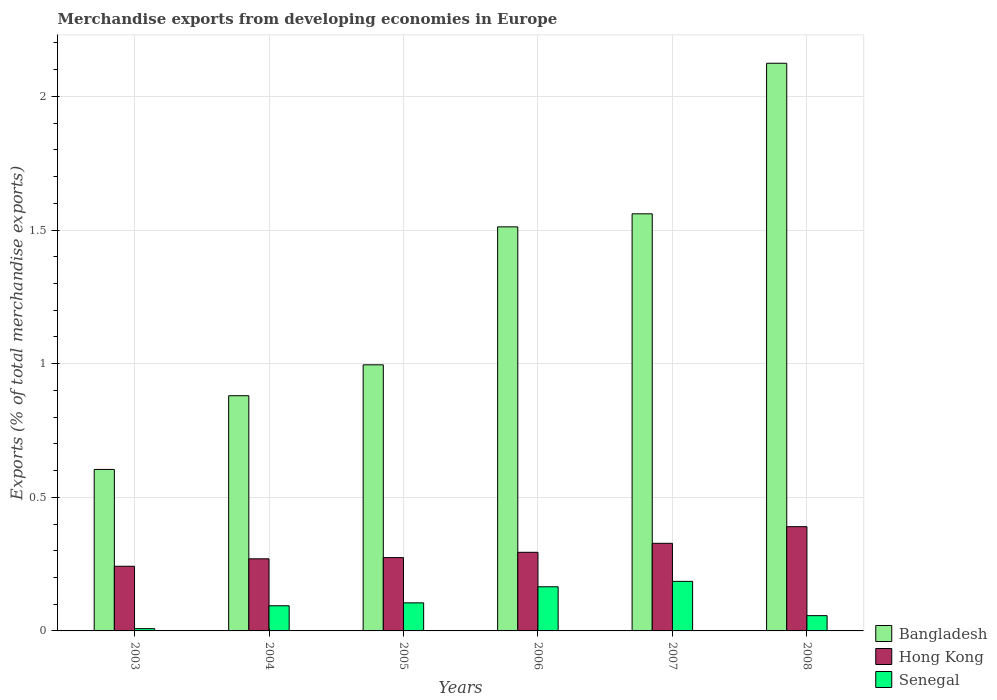How many different coloured bars are there?
Make the answer very short. 3. How many groups of bars are there?
Give a very brief answer. 6. How many bars are there on the 3rd tick from the right?
Your answer should be compact. 3. In how many cases, is the number of bars for a given year not equal to the number of legend labels?
Provide a succinct answer. 0. What is the percentage of total merchandise exports in Senegal in 2003?
Your response must be concise. 0.01. Across all years, what is the maximum percentage of total merchandise exports in Bangladesh?
Your answer should be very brief. 2.12. Across all years, what is the minimum percentage of total merchandise exports in Hong Kong?
Your answer should be very brief. 0.24. In which year was the percentage of total merchandise exports in Bangladesh maximum?
Your answer should be very brief. 2008. In which year was the percentage of total merchandise exports in Bangladesh minimum?
Offer a very short reply. 2003. What is the total percentage of total merchandise exports in Bangladesh in the graph?
Provide a short and direct response. 7.68. What is the difference between the percentage of total merchandise exports in Bangladesh in 2003 and that in 2008?
Make the answer very short. -1.52. What is the difference between the percentage of total merchandise exports in Hong Kong in 2007 and the percentage of total merchandise exports in Senegal in 2003?
Provide a short and direct response. 0.32. What is the average percentage of total merchandise exports in Bangladesh per year?
Make the answer very short. 1.28. In the year 2007, what is the difference between the percentage of total merchandise exports in Hong Kong and percentage of total merchandise exports in Bangladesh?
Your answer should be very brief. -1.23. In how many years, is the percentage of total merchandise exports in Bangladesh greater than 0.7 %?
Provide a short and direct response. 5. What is the ratio of the percentage of total merchandise exports in Bangladesh in 2006 to that in 2007?
Provide a succinct answer. 0.97. What is the difference between the highest and the second highest percentage of total merchandise exports in Hong Kong?
Your answer should be very brief. 0.06. What is the difference between the highest and the lowest percentage of total merchandise exports in Hong Kong?
Your answer should be compact. 0.15. Is the sum of the percentage of total merchandise exports in Senegal in 2005 and 2008 greater than the maximum percentage of total merchandise exports in Hong Kong across all years?
Provide a succinct answer. No. What does the 1st bar from the left in 2005 represents?
Offer a very short reply. Bangladesh. What does the 2nd bar from the right in 2003 represents?
Provide a short and direct response. Hong Kong. How many years are there in the graph?
Offer a very short reply. 6. What is the difference between two consecutive major ticks on the Y-axis?
Provide a short and direct response. 0.5. Are the values on the major ticks of Y-axis written in scientific E-notation?
Ensure brevity in your answer.  No. Does the graph contain grids?
Offer a very short reply. Yes. How many legend labels are there?
Make the answer very short. 3. How are the legend labels stacked?
Keep it short and to the point. Vertical. What is the title of the graph?
Provide a succinct answer. Merchandise exports from developing economies in Europe. What is the label or title of the Y-axis?
Provide a succinct answer. Exports (% of total merchandise exports). What is the Exports (% of total merchandise exports) of Bangladesh in 2003?
Give a very brief answer. 0.6. What is the Exports (% of total merchandise exports) of Hong Kong in 2003?
Offer a very short reply. 0.24. What is the Exports (% of total merchandise exports) of Senegal in 2003?
Your answer should be very brief. 0.01. What is the Exports (% of total merchandise exports) of Bangladesh in 2004?
Your answer should be very brief. 0.88. What is the Exports (% of total merchandise exports) in Hong Kong in 2004?
Provide a short and direct response. 0.27. What is the Exports (% of total merchandise exports) of Senegal in 2004?
Offer a terse response. 0.09. What is the Exports (% of total merchandise exports) in Bangladesh in 2005?
Provide a short and direct response. 1. What is the Exports (% of total merchandise exports) in Hong Kong in 2005?
Provide a succinct answer. 0.27. What is the Exports (% of total merchandise exports) of Senegal in 2005?
Your response must be concise. 0.11. What is the Exports (% of total merchandise exports) of Bangladesh in 2006?
Your response must be concise. 1.51. What is the Exports (% of total merchandise exports) of Hong Kong in 2006?
Keep it short and to the point. 0.29. What is the Exports (% of total merchandise exports) in Senegal in 2006?
Offer a very short reply. 0.17. What is the Exports (% of total merchandise exports) in Bangladesh in 2007?
Your answer should be compact. 1.56. What is the Exports (% of total merchandise exports) in Hong Kong in 2007?
Your response must be concise. 0.33. What is the Exports (% of total merchandise exports) of Senegal in 2007?
Provide a short and direct response. 0.19. What is the Exports (% of total merchandise exports) of Bangladesh in 2008?
Keep it short and to the point. 2.12. What is the Exports (% of total merchandise exports) of Hong Kong in 2008?
Ensure brevity in your answer.  0.39. What is the Exports (% of total merchandise exports) of Senegal in 2008?
Your response must be concise. 0.06. Across all years, what is the maximum Exports (% of total merchandise exports) in Bangladesh?
Your answer should be very brief. 2.12. Across all years, what is the maximum Exports (% of total merchandise exports) in Hong Kong?
Give a very brief answer. 0.39. Across all years, what is the maximum Exports (% of total merchandise exports) in Senegal?
Ensure brevity in your answer.  0.19. Across all years, what is the minimum Exports (% of total merchandise exports) in Bangladesh?
Your response must be concise. 0.6. Across all years, what is the minimum Exports (% of total merchandise exports) of Hong Kong?
Offer a terse response. 0.24. Across all years, what is the minimum Exports (% of total merchandise exports) in Senegal?
Your answer should be very brief. 0.01. What is the total Exports (% of total merchandise exports) in Bangladesh in the graph?
Provide a succinct answer. 7.68. What is the total Exports (% of total merchandise exports) of Hong Kong in the graph?
Offer a terse response. 1.8. What is the total Exports (% of total merchandise exports) in Senegal in the graph?
Keep it short and to the point. 0.62. What is the difference between the Exports (% of total merchandise exports) of Bangladesh in 2003 and that in 2004?
Offer a very short reply. -0.28. What is the difference between the Exports (% of total merchandise exports) of Hong Kong in 2003 and that in 2004?
Give a very brief answer. -0.03. What is the difference between the Exports (% of total merchandise exports) of Senegal in 2003 and that in 2004?
Give a very brief answer. -0.09. What is the difference between the Exports (% of total merchandise exports) in Bangladesh in 2003 and that in 2005?
Provide a succinct answer. -0.39. What is the difference between the Exports (% of total merchandise exports) in Hong Kong in 2003 and that in 2005?
Provide a short and direct response. -0.03. What is the difference between the Exports (% of total merchandise exports) of Senegal in 2003 and that in 2005?
Your answer should be very brief. -0.1. What is the difference between the Exports (% of total merchandise exports) of Bangladesh in 2003 and that in 2006?
Give a very brief answer. -0.91. What is the difference between the Exports (% of total merchandise exports) of Hong Kong in 2003 and that in 2006?
Ensure brevity in your answer.  -0.05. What is the difference between the Exports (% of total merchandise exports) of Senegal in 2003 and that in 2006?
Offer a terse response. -0.16. What is the difference between the Exports (% of total merchandise exports) in Bangladesh in 2003 and that in 2007?
Provide a short and direct response. -0.96. What is the difference between the Exports (% of total merchandise exports) in Hong Kong in 2003 and that in 2007?
Your answer should be compact. -0.09. What is the difference between the Exports (% of total merchandise exports) of Senegal in 2003 and that in 2007?
Ensure brevity in your answer.  -0.18. What is the difference between the Exports (% of total merchandise exports) of Bangladesh in 2003 and that in 2008?
Ensure brevity in your answer.  -1.52. What is the difference between the Exports (% of total merchandise exports) of Hong Kong in 2003 and that in 2008?
Provide a succinct answer. -0.15. What is the difference between the Exports (% of total merchandise exports) in Senegal in 2003 and that in 2008?
Give a very brief answer. -0.05. What is the difference between the Exports (% of total merchandise exports) of Bangladesh in 2004 and that in 2005?
Provide a short and direct response. -0.12. What is the difference between the Exports (% of total merchandise exports) in Hong Kong in 2004 and that in 2005?
Make the answer very short. -0. What is the difference between the Exports (% of total merchandise exports) in Senegal in 2004 and that in 2005?
Your answer should be very brief. -0.01. What is the difference between the Exports (% of total merchandise exports) in Bangladesh in 2004 and that in 2006?
Provide a short and direct response. -0.63. What is the difference between the Exports (% of total merchandise exports) of Hong Kong in 2004 and that in 2006?
Give a very brief answer. -0.02. What is the difference between the Exports (% of total merchandise exports) in Senegal in 2004 and that in 2006?
Give a very brief answer. -0.07. What is the difference between the Exports (% of total merchandise exports) in Bangladesh in 2004 and that in 2007?
Your response must be concise. -0.68. What is the difference between the Exports (% of total merchandise exports) of Hong Kong in 2004 and that in 2007?
Give a very brief answer. -0.06. What is the difference between the Exports (% of total merchandise exports) in Senegal in 2004 and that in 2007?
Provide a short and direct response. -0.09. What is the difference between the Exports (% of total merchandise exports) in Bangladesh in 2004 and that in 2008?
Provide a short and direct response. -1.24. What is the difference between the Exports (% of total merchandise exports) of Hong Kong in 2004 and that in 2008?
Your response must be concise. -0.12. What is the difference between the Exports (% of total merchandise exports) of Senegal in 2004 and that in 2008?
Provide a succinct answer. 0.04. What is the difference between the Exports (% of total merchandise exports) of Bangladesh in 2005 and that in 2006?
Your answer should be very brief. -0.52. What is the difference between the Exports (% of total merchandise exports) in Hong Kong in 2005 and that in 2006?
Keep it short and to the point. -0.02. What is the difference between the Exports (% of total merchandise exports) in Senegal in 2005 and that in 2006?
Ensure brevity in your answer.  -0.06. What is the difference between the Exports (% of total merchandise exports) of Bangladesh in 2005 and that in 2007?
Your answer should be very brief. -0.56. What is the difference between the Exports (% of total merchandise exports) of Hong Kong in 2005 and that in 2007?
Your answer should be very brief. -0.05. What is the difference between the Exports (% of total merchandise exports) in Senegal in 2005 and that in 2007?
Give a very brief answer. -0.08. What is the difference between the Exports (% of total merchandise exports) of Bangladesh in 2005 and that in 2008?
Make the answer very short. -1.13. What is the difference between the Exports (% of total merchandise exports) of Hong Kong in 2005 and that in 2008?
Offer a very short reply. -0.12. What is the difference between the Exports (% of total merchandise exports) in Senegal in 2005 and that in 2008?
Your answer should be very brief. 0.05. What is the difference between the Exports (% of total merchandise exports) of Bangladesh in 2006 and that in 2007?
Offer a very short reply. -0.05. What is the difference between the Exports (% of total merchandise exports) of Hong Kong in 2006 and that in 2007?
Offer a very short reply. -0.03. What is the difference between the Exports (% of total merchandise exports) in Senegal in 2006 and that in 2007?
Provide a short and direct response. -0.02. What is the difference between the Exports (% of total merchandise exports) in Bangladesh in 2006 and that in 2008?
Provide a succinct answer. -0.61. What is the difference between the Exports (% of total merchandise exports) in Hong Kong in 2006 and that in 2008?
Ensure brevity in your answer.  -0.1. What is the difference between the Exports (% of total merchandise exports) of Senegal in 2006 and that in 2008?
Provide a short and direct response. 0.11. What is the difference between the Exports (% of total merchandise exports) of Bangladesh in 2007 and that in 2008?
Ensure brevity in your answer.  -0.56. What is the difference between the Exports (% of total merchandise exports) in Hong Kong in 2007 and that in 2008?
Your answer should be compact. -0.06. What is the difference between the Exports (% of total merchandise exports) in Senegal in 2007 and that in 2008?
Give a very brief answer. 0.13. What is the difference between the Exports (% of total merchandise exports) of Bangladesh in 2003 and the Exports (% of total merchandise exports) of Hong Kong in 2004?
Your answer should be compact. 0.33. What is the difference between the Exports (% of total merchandise exports) in Bangladesh in 2003 and the Exports (% of total merchandise exports) in Senegal in 2004?
Give a very brief answer. 0.51. What is the difference between the Exports (% of total merchandise exports) of Hong Kong in 2003 and the Exports (% of total merchandise exports) of Senegal in 2004?
Offer a terse response. 0.15. What is the difference between the Exports (% of total merchandise exports) of Bangladesh in 2003 and the Exports (% of total merchandise exports) of Hong Kong in 2005?
Your answer should be compact. 0.33. What is the difference between the Exports (% of total merchandise exports) of Bangladesh in 2003 and the Exports (% of total merchandise exports) of Senegal in 2005?
Your answer should be very brief. 0.5. What is the difference between the Exports (% of total merchandise exports) in Hong Kong in 2003 and the Exports (% of total merchandise exports) in Senegal in 2005?
Your answer should be compact. 0.14. What is the difference between the Exports (% of total merchandise exports) of Bangladesh in 2003 and the Exports (% of total merchandise exports) of Hong Kong in 2006?
Make the answer very short. 0.31. What is the difference between the Exports (% of total merchandise exports) of Bangladesh in 2003 and the Exports (% of total merchandise exports) of Senegal in 2006?
Ensure brevity in your answer.  0.44. What is the difference between the Exports (% of total merchandise exports) of Hong Kong in 2003 and the Exports (% of total merchandise exports) of Senegal in 2006?
Offer a terse response. 0.08. What is the difference between the Exports (% of total merchandise exports) in Bangladesh in 2003 and the Exports (% of total merchandise exports) in Hong Kong in 2007?
Provide a succinct answer. 0.28. What is the difference between the Exports (% of total merchandise exports) in Bangladesh in 2003 and the Exports (% of total merchandise exports) in Senegal in 2007?
Keep it short and to the point. 0.42. What is the difference between the Exports (% of total merchandise exports) in Hong Kong in 2003 and the Exports (% of total merchandise exports) in Senegal in 2007?
Offer a very short reply. 0.06. What is the difference between the Exports (% of total merchandise exports) in Bangladesh in 2003 and the Exports (% of total merchandise exports) in Hong Kong in 2008?
Your answer should be compact. 0.21. What is the difference between the Exports (% of total merchandise exports) in Bangladesh in 2003 and the Exports (% of total merchandise exports) in Senegal in 2008?
Ensure brevity in your answer.  0.55. What is the difference between the Exports (% of total merchandise exports) of Hong Kong in 2003 and the Exports (% of total merchandise exports) of Senegal in 2008?
Your answer should be very brief. 0.18. What is the difference between the Exports (% of total merchandise exports) in Bangladesh in 2004 and the Exports (% of total merchandise exports) in Hong Kong in 2005?
Offer a very short reply. 0.61. What is the difference between the Exports (% of total merchandise exports) in Bangladesh in 2004 and the Exports (% of total merchandise exports) in Senegal in 2005?
Your answer should be very brief. 0.78. What is the difference between the Exports (% of total merchandise exports) of Hong Kong in 2004 and the Exports (% of total merchandise exports) of Senegal in 2005?
Keep it short and to the point. 0.16. What is the difference between the Exports (% of total merchandise exports) of Bangladesh in 2004 and the Exports (% of total merchandise exports) of Hong Kong in 2006?
Your answer should be very brief. 0.59. What is the difference between the Exports (% of total merchandise exports) in Bangladesh in 2004 and the Exports (% of total merchandise exports) in Senegal in 2006?
Ensure brevity in your answer.  0.71. What is the difference between the Exports (% of total merchandise exports) in Hong Kong in 2004 and the Exports (% of total merchandise exports) in Senegal in 2006?
Provide a succinct answer. 0.1. What is the difference between the Exports (% of total merchandise exports) of Bangladesh in 2004 and the Exports (% of total merchandise exports) of Hong Kong in 2007?
Give a very brief answer. 0.55. What is the difference between the Exports (% of total merchandise exports) of Bangladesh in 2004 and the Exports (% of total merchandise exports) of Senegal in 2007?
Make the answer very short. 0.69. What is the difference between the Exports (% of total merchandise exports) of Hong Kong in 2004 and the Exports (% of total merchandise exports) of Senegal in 2007?
Provide a succinct answer. 0.08. What is the difference between the Exports (% of total merchandise exports) in Bangladesh in 2004 and the Exports (% of total merchandise exports) in Hong Kong in 2008?
Ensure brevity in your answer.  0.49. What is the difference between the Exports (% of total merchandise exports) in Bangladesh in 2004 and the Exports (% of total merchandise exports) in Senegal in 2008?
Offer a terse response. 0.82. What is the difference between the Exports (% of total merchandise exports) of Hong Kong in 2004 and the Exports (% of total merchandise exports) of Senegal in 2008?
Your answer should be very brief. 0.21. What is the difference between the Exports (% of total merchandise exports) in Bangladesh in 2005 and the Exports (% of total merchandise exports) in Hong Kong in 2006?
Offer a terse response. 0.7. What is the difference between the Exports (% of total merchandise exports) of Bangladesh in 2005 and the Exports (% of total merchandise exports) of Senegal in 2006?
Make the answer very short. 0.83. What is the difference between the Exports (% of total merchandise exports) in Hong Kong in 2005 and the Exports (% of total merchandise exports) in Senegal in 2006?
Your response must be concise. 0.11. What is the difference between the Exports (% of total merchandise exports) in Bangladesh in 2005 and the Exports (% of total merchandise exports) in Hong Kong in 2007?
Provide a short and direct response. 0.67. What is the difference between the Exports (% of total merchandise exports) in Bangladesh in 2005 and the Exports (% of total merchandise exports) in Senegal in 2007?
Provide a short and direct response. 0.81. What is the difference between the Exports (% of total merchandise exports) of Hong Kong in 2005 and the Exports (% of total merchandise exports) of Senegal in 2007?
Your answer should be compact. 0.09. What is the difference between the Exports (% of total merchandise exports) in Bangladesh in 2005 and the Exports (% of total merchandise exports) in Hong Kong in 2008?
Give a very brief answer. 0.61. What is the difference between the Exports (% of total merchandise exports) in Bangladesh in 2005 and the Exports (% of total merchandise exports) in Senegal in 2008?
Your response must be concise. 0.94. What is the difference between the Exports (% of total merchandise exports) in Hong Kong in 2005 and the Exports (% of total merchandise exports) in Senegal in 2008?
Provide a short and direct response. 0.22. What is the difference between the Exports (% of total merchandise exports) of Bangladesh in 2006 and the Exports (% of total merchandise exports) of Hong Kong in 2007?
Offer a very short reply. 1.18. What is the difference between the Exports (% of total merchandise exports) in Bangladesh in 2006 and the Exports (% of total merchandise exports) in Senegal in 2007?
Provide a short and direct response. 1.33. What is the difference between the Exports (% of total merchandise exports) of Hong Kong in 2006 and the Exports (% of total merchandise exports) of Senegal in 2007?
Your answer should be compact. 0.11. What is the difference between the Exports (% of total merchandise exports) in Bangladesh in 2006 and the Exports (% of total merchandise exports) in Hong Kong in 2008?
Your response must be concise. 1.12. What is the difference between the Exports (% of total merchandise exports) in Bangladesh in 2006 and the Exports (% of total merchandise exports) in Senegal in 2008?
Provide a succinct answer. 1.45. What is the difference between the Exports (% of total merchandise exports) in Hong Kong in 2006 and the Exports (% of total merchandise exports) in Senegal in 2008?
Provide a short and direct response. 0.24. What is the difference between the Exports (% of total merchandise exports) in Bangladesh in 2007 and the Exports (% of total merchandise exports) in Hong Kong in 2008?
Give a very brief answer. 1.17. What is the difference between the Exports (% of total merchandise exports) in Bangladesh in 2007 and the Exports (% of total merchandise exports) in Senegal in 2008?
Make the answer very short. 1.5. What is the difference between the Exports (% of total merchandise exports) of Hong Kong in 2007 and the Exports (% of total merchandise exports) of Senegal in 2008?
Provide a succinct answer. 0.27. What is the average Exports (% of total merchandise exports) of Bangladesh per year?
Offer a very short reply. 1.28. What is the average Exports (% of total merchandise exports) of Hong Kong per year?
Your answer should be compact. 0.3. What is the average Exports (% of total merchandise exports) in Senegal per year?
Your answer should be compact. 0.1. In the year 2003, what is the difference between the Exports (% of total merchandise exports) of Bangladesh and Exports (% of total merchandise exports) of Hong Kong?
Give a very brief answer. 0.36. In the year 2003, what is the difference between the Exports (% of total merchandise exports) in Bangladesh and Exports (% of total merchandise exports) in Senegal?
Keep it short and to the point. 0.6. In the year 2003, what is the difference between the Exports (% of total merchandise exports) of Hong Kong and Exports (% of total merchandise exports) of Senegal?
Provide a short and direct response. 0.23. In the year 2004, what is the difference between the Exports (% of total merchandise exports) of Bangladesh and Exports (% of total merchandise exports) of Hong Kong?
Make the answer very short. 0.61. In the year 2004, what is the difference between the Exports (% of total merchandise exports) of Bangladesh and Exports (% of total merchandise exports) of Senegal?
Make the answer very short. 0.79. In the year 2004, what is the difference between the Exports (% of total merchandise exports) of Hong Kong and Exports (% of total merchandise exports) of Senegal?
Offer a terse response. 0.18. In the year 2005, what is the difference between the Exports (% of total merchandise exports) of Bangladesh and Exports (% of total merchandise exports) of Hong Kong?
Ensure brevity in your answer.  0.72. In the year 2005, what is the difference between the Exports (% of total merchandise exports) in Bangladesh and Exports (% of total merchandise exports) in Senegal?
Ensure brevity in your answer.  0.89. In the year 2005, what is the difference between the Exports (% of total merchandise exports) in Hong Kong and Exports (% of total merchandise exports) in Senegal?
Provide a succinct answer. 0.17. In the year 2006, what is the difference between the Exports (% of total merchandise exports) of Bangladesh and Exports (% of total merchandise exports) of Hong Kong?
Provide a short and direct response. 1.22. In the year 2006, what is the difference between the Exports (% of total merchandise exports) of Bangladesh and Exports (% of total merchandise exports) of Senegal?
Offer a terse response. 1.35. In the year 2006, what is the difference between the Exports (% of total merchandise exports) in Hong Kong and Exports (% of total merchandise exports) in Senegal?
Your response must be concise. 0.13. In the year 2007, what is the difference between the Exports (% of total merchandise exports) in Bangladesh and Exports (% of total merchandise exports) in Hong Kong?
Keep it short and to the point. 1.23. In the year 2007, what is the difference between the Exports (% of total merchandise exports) in Bangladesh and Exports (% of total merchandise exports) in Senegal?
Provide a succinct answer. 1.38. In the year 2007, what is the difference between the Exports (% of total merchandise exports) of Hong Kong and Exports (% of total merchandise exports) of Senegal?
Ensure brevity in your answer.  0.14. In the year 2008, what is the difference between the Exports (% of total merchandise exports) in Bangladesh and Exports (% of total merchandise exports) in Hong Kong?
Your answer should be very brief. 1.73. In the year 2008, what is the difference between the Exports (% of total merchandise exports) in Bangladesh and Exports (% of total merchandise exports) in Senegal?
Ensure brevity in your answer.  2.07. In the year 2008, what is the difference between the Exports (% of total merchandise exports) of Hong Kong and Exports (% of total merchandise exports) of Senegal?
Offer a very short reply. 0.33. What is the ratio of the Exports (% of total merchandise exports) in Bangladesh in 2003 to that in 2004?
Give a very brief answer. 0.69. What is the ratio of the Exports (% of total merchandise exports) of Hong Kong in 2003 to that in 2004?
Your answer should be compact. 0.9. What is the ratio of the Exports (% of total merchandise exports) in Senegal in 2003 to that in 2004?
Give a very brief answer. 0.09. What is the ratio of the Exports (% of total merchandise exports) in Bangladesh in 2003 to that in 2005?
Provide a succinct answer. 0.61. What is the ratio of the Exports (% of total merchandise exports) in Hong Kong in 2003 to that in 2005?
Offer a very short reply. 0.88. What is the ratio of the Exports (% of total merchandise exports) in Senegal in 2003 to that in 2005?
Offer a very short reply. 0.08. What is the ratio of the Exports (% of total merchandise exports) in Bangladesh in 2003 to that in 2006?
Offer a terse response. 0.4. What is the ratio of the Exports (% of total merchandise exports) in Hong Kong in 2003 to that in 2006?
Ensure brevity in your answer.  0.82. What is the ratio of the Exports (% of total merchandise exports) in Senegal in 2003 to that in 2006?
Make the answer very short. 0.05. What is the ratio of the Exports (% of total merchandise exports) of Bangladesh in 2003 to that in 2007?
Your response must be concise. 0.39. What is the ratio of the Exports (% of total merchandise exports) of Hong Kong in 2003 to that in 2007?
Give a very brief answer. 0.74. What is the ratio of the Exports (% of total merchandise exports) of Senegal in 2003 to that in 2007?
Ensure brevity in your answer.  0.05. What is the ratio of the Exports (% of total merchandise exports) in Bangladesh in 2003 to that in 2008?
Offer a terse response. 0.28. What is the ratio of the Exports (% of total merchandise exports) in Hong Kong in 2003 to that in 2008?
Provide a succinct answer. 0.62. What is the ratio of the Exports (% of total merchandise exports) of Senegal in 2003 to that in 2008?
Provide a succinct answer. 0.15. What is the ratio of the Exports (% of total merchandise exports) of Bangladesh in 2004 to that in 2005?
Your response must be concise. 0.88. What is the ratio of the Exports (% of total merchandise exports) in Hong Kong in 2004 to that in 2005?
Give a very brief answer. 0.98. What is the ratio of the Exports (% of total merchandise exports) of Senegal in 2004 to that in 2005?
Give a very brief answer. 0.9. What is the ratio of the Exports (% of total merchandise exports) of Bangladesh in 2004 to that in 2006?
Offer a very short reply. 0.58. What is the ratio of the Exports (% of total merchandise exports) of Hong Kong in 2004 to that in 2006?
Offer a very short reply. 0.92. What is the ratio of the Exports (% of total merchandise exports) in Senegal in 2004 to that in 2006?
Make the answer very short. 0.57. What is the ratio of the Exports (% of total merchandise exports) of Bangladesh in 2004 to that in 2007?
Provide a short and direct response. 0.56. What is the ratio of the Exports (% of total merchandise exports) in Hong Kong in 2004 to that in 2007?
Ensure brevity in your answer.  0.82. What is the ratio of the Exports (% of total merchandise exports) of Senegal in 2004 to that in 2007?
Offer a terse response. 0.51. What is the ratio of the Exports (% of total merchandise exports) of Bangladesh in 2004 to that in 2008?
Make the answer very short. 0.41. What is the ratio of the Exports (% of total merchandise exports) in Hong Kong in 2004 to that in 2008?
Offer a very short reply. 0.69. What is the ratio of the Exports (% of total merchandise exports) in Senegal in 2004 to that in 2008?
Your answer should be compact. 1.65. What is the ratio of the Exports (% of total merchandise exports) in Bangladesh in 2005 to that in 2006?
Make the answer very short. 0.66. What is the ratio of the Exports (% of total merchandise exports) in Hong Kong in 2005 to that in 2006?
Keep it short and to the point. 0.93. What is the ratio of the Exports (% of total merchandise exports) of Senegal in 2005 to that in 2006?
Ensure brevity in your answer.  0.64. What is the ratio of the Exports (% of total merchandise exports) in Bangladesh in 2005 to that in 2007?
Provide a short and direct response. 0.64. What is the ratio of the Exports (% of total merchandise exports) of Hong Kong in 2005 to that in 2007?
Ensure brevity in your answer.  0.84. What is the ratio of the Exports (% of total merchandise exports) of Senegal in 2005 to that in 2007?
Ensure brevity in your answer.  0.57. What is the ratio of the Exports (% of total merchandise exports) of Bangladesh in 2005 to that in 2008?
Your answer should be compact. 0.47. What is the ratio of the Exports (% of total merchandise exports) of Hong Kong in 2005 to that in 2008?
Keep it short and to the point. 0.7. What is the ratio of the Exports (% of total merchandise exports) in Senegal in 2005 to that in 2008?
Provide a short and direct response. 1.84. What is the ratio of the Exports (% of total merchandise exports) of Bangladesh in 2006 to that in 2007?
Your answer should be compact. 0.97. What is the ratio of the Exports (% of total merchandise exports) of Hong Kong in 2006 to that in 2007?
Your response must be concise. 0.9. What is the ratio of the Exports (% of total merchandise exports) of Senegal in 2006 to that in 2007?
Your answer should be very brief. 0.89. What is the ratio of the Exports (% of total merchandise exports) of Bangladesh in 2006 to that in 2008?
Provide a succinct answer. 0.71. What is the ratio of the Exports (% of total merchandise exports) in Hong Kong in 2006 to that in 2008?
Provide a succinct answer. 0.75. What is the ratio of the Exports (% of total merchandise exports) of Senegal in 2006 to that in 2008?
Ensure brevity in your answer.  2.89. What is the ratio of the Exports (% of total merchandise exports) of Bangladesh in 2007 to that in 2008?
Offer a very short reply. 0.73. What is the ratio of the Exports (% of total merchandise exports) of Hong Kong in 2007 to that in 2008?
Give a very brief answer. 0.84. What is the ratio of the Exports (% of total merchandise exports) in Senegal in 2007 to that in 2008?
Make the answer very short. 3.25. What is the difference between the highest and the second highest Exports (% of total merchandise exports) of Bangladesh?
Give a very brief answer. 0.56. What is the difference between the highest and the second highest Exports (% of total merchandise exports) in Hong Kong?
Offer a very short reply. 0.06. What is the difference between the highest and the second highest Exports (% of total merchandise exports) in Senegal?
Keep it short and to the point. 0.02. What is the difference between the highest and the lowest Exports (% of total merchandise exports) of Bangladesh?
Keep it short and to the point. 1.52. What is the difference between the highest and the lowest Exports (% of total merchandise exports) in Hong Kong?
Your answer should be compact. 0.15. What is the difference between the highest and the lowest Exports (% of total merchandise exports) of Senegal?
Offer a terse response. 0.18. 